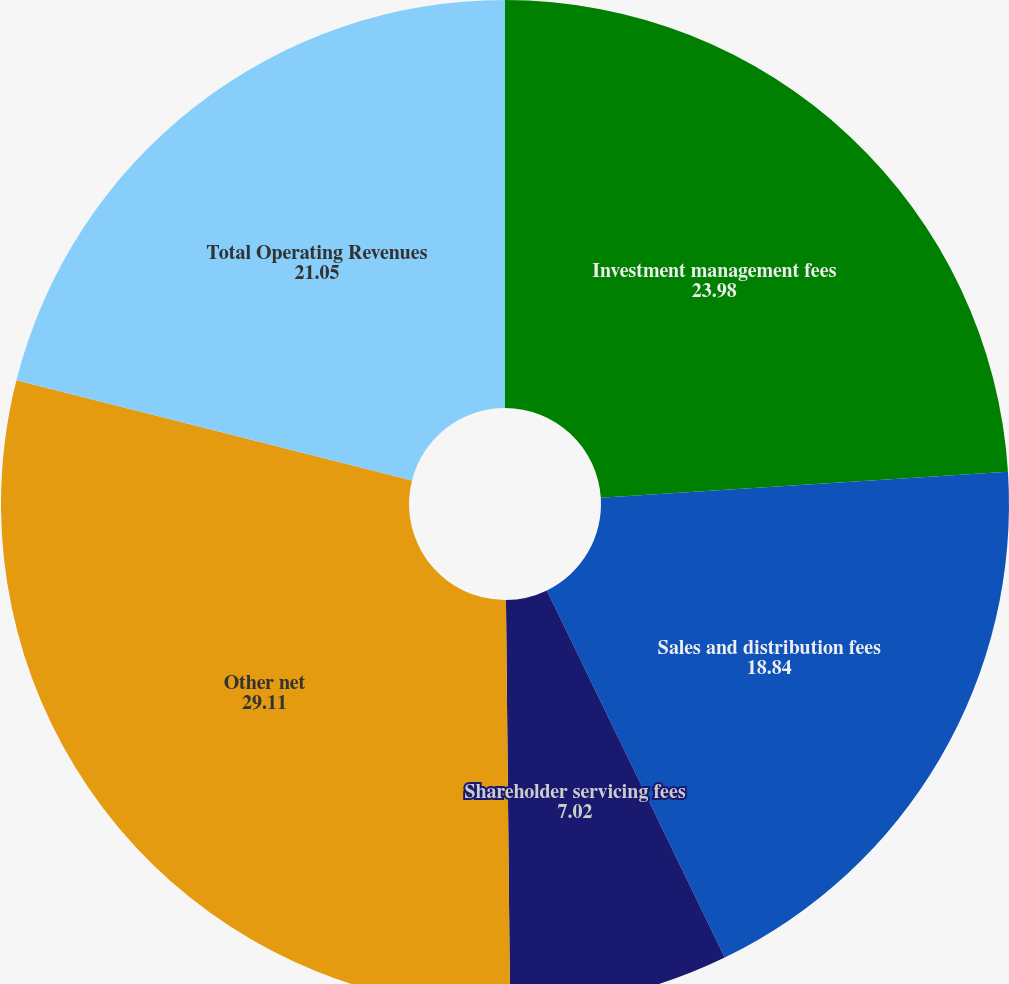Convert chart. <chart><loc_0><loc_0><loc_500><loc_500><pie_chart><fcel>Investment management fees<fcel>Sales and distribution fees<fcel>Shareholder servicing fees<fcel>Other net<fcel>Total Operating Revenues<nl><fcel>23.98%<fcel>18.84%<fcel>7.02%<fcel>29.11%<fcel>21.05%<nl></chart> 